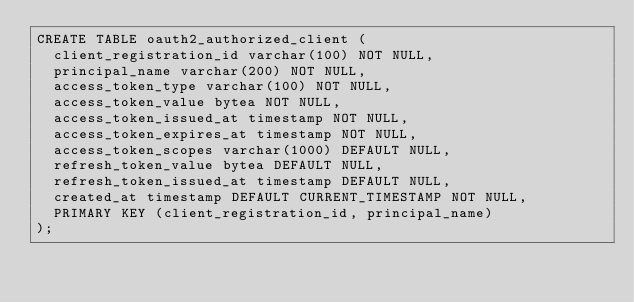<code> <loc_0><loc_0><loc_500><loc_500><_SQL_>CREATE TABLE oauth2_authorized_client (
  client_registration_id varchar(100) NOT NULL,
  principal_name varchar(200) NOT NULL,
  access_token_type varchar(100) NOT NULL,
  access_token_value bytea NOT NULL,
  access_token_issued_at timestamp NOT NULL,
  access_token_expires_at timestamp NOT NULL,
  access_token_scopes varchar(1000) DEFAULT NULL,
  refresh_token_value bytea DEFAULT NULL,
  refresh_token_issued_at timestamp DEFAULT NULL,
  created_at timestamp DEFAULT CURRENT_TIMESTAMP NOT NULL,
  PRIMARY KEY (client_registration_id, principal_name)
);
</code> 